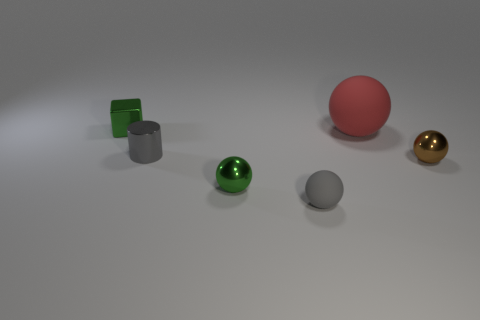Is there anything else that has the same shape as the gray metal thing?
Your answer should be compact. No. What is the color of the rubber object behind the gray object in front of the tiny cylinder?
Offer a very short reply. Red. What shape is the big rubber object that is in front of the green object that is behind the metal ball to the right of the small gray matte object?
Keep it short and to the point. Sphere. What is the size of the metal thing that is both in front of the gray metal cylinder and to the left of the large sphere?
Offer a very short reply. Small. What number of small cylinders have the same color as the small rubber thing?
Ensure brevity in your answer.  1. There is another tiny thing that is the same color as the small matte thing; what is it made of?
Offer a very short reply. Metal. What is the cylinder made of?
Your answer should be very brief. Metal. Is the material of the big red object that is in front of the tiny green shiny cube the same as the small gray ball?
Give a very brief answer. Yes. There is a tiny green object behind the small green sphere; what shape is it?
Provide a succinct answer. Cube. There is a green cube that is the same size as the gray cylinder; what material is it?
Your answer should be very brief. Metal. 